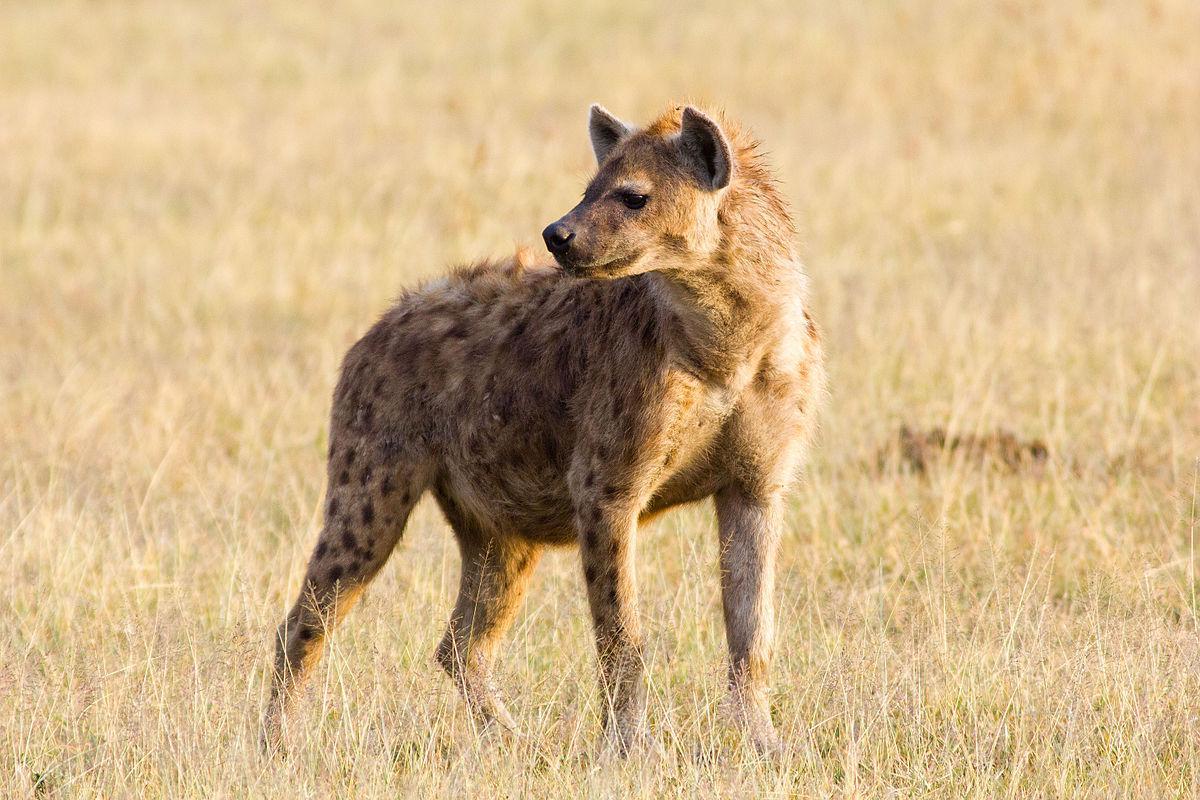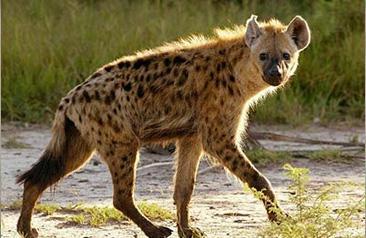The first image is the image on the left, the second image is the image on the right. Examine the images to the left and right. Is the description "A hyena has its mouth wide open" accurate? Answer yes or no. No. 